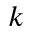<formula> <loc_0><loc_0><loc_500><loc_500>k</formula> 